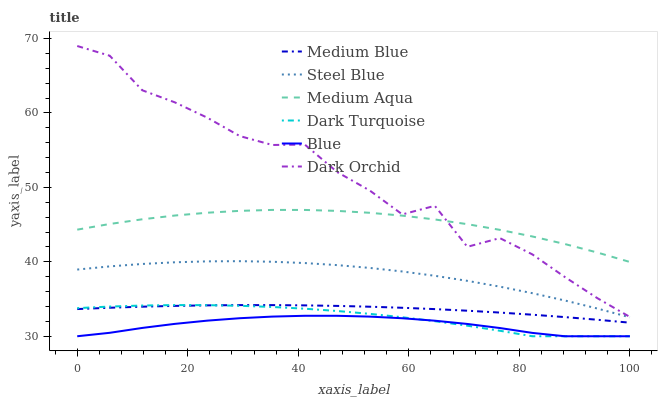Does Blue have the minimum area under the curve?
Answer yes or no. Yes. Does Dark Orchid have the maximum area under the curve?
Answer yes or no. Yes. Does Dark Turquoise have the minimum area under the curve?
Answer yes or no. No. Does Dark Turquoise have the maximum area under the curve?
Answer yes or no. No. Is Medium Blue the smoothest?
Answer yes or no. Yes. Is Dark Orchid the roughest?
Answer yes or no. Yes. Is Dark Turquoise the smoothest?
Answer yes or no. No. Is Dark Turquoise the roughest?
Answer yes or no. No. Does Blue have the lowest value?
Answer yes or no. Yes. Does Medium Blue have the lowest value?
Answer yes or no. No. Does Dark Orchid have the highest value?
Answer yes or no. Yes. Does Dark Turquoise have the highest value?
Answer yes or no. No. Is Steel Blue less than Dark Orchid?
Answer yes or no. Yes. Is Dark Orchid greater than Medium Blue?
Answer yes or no. Yes. Does Dark Turquoise intersect Blue?
Answer yes or no. Yes. Is Dark Turquoise less than Blue?
Answer yes or no. No. Is Dark Turquoise greater than Blue?
Answer yes or no. No. Does Steel Blue intersect Dark Orchid?
Answer yes or no. No. 